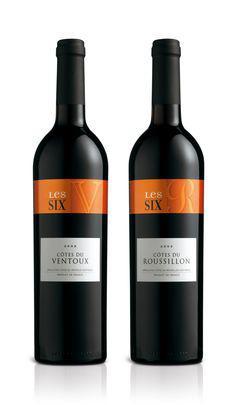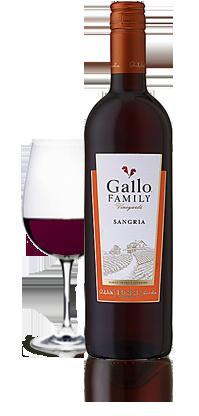The first image is the image on the left, the second image is the image on the right. Assess this claim about the two images: "There is a wine glass visible on one of the images.". Correct or not? Answer yes or no. Yes. 